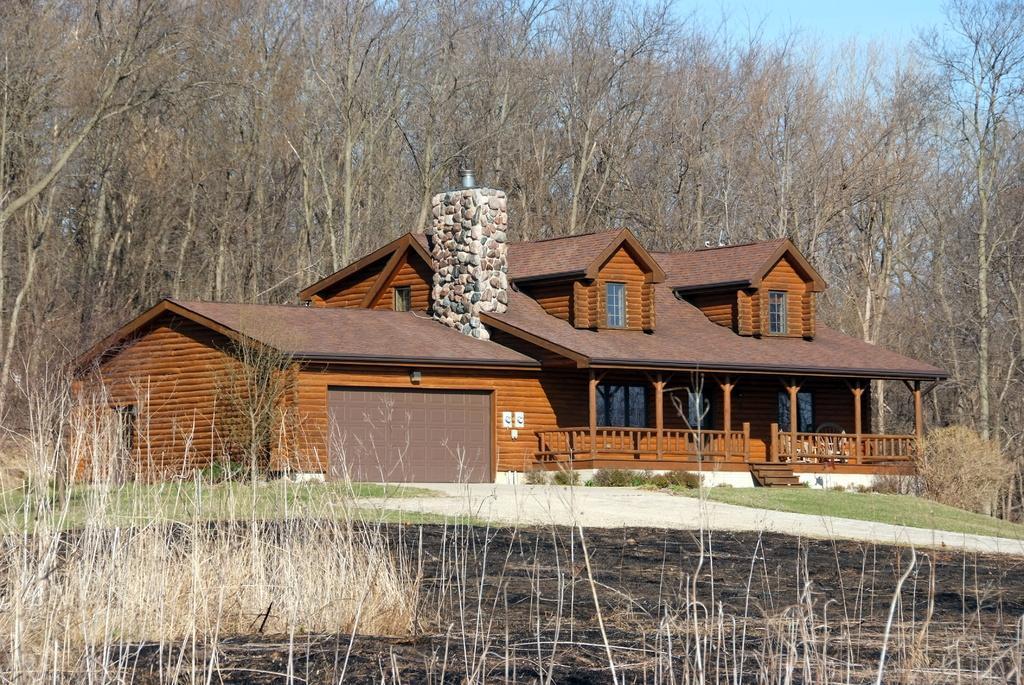Please provide a concise description of this image. In the foreground of the picture there are dry grass and field. In the center of the picture there are plants, house, windows, chimney, path and grass. In the background there are trees. Sky is clear and it is sunny. 